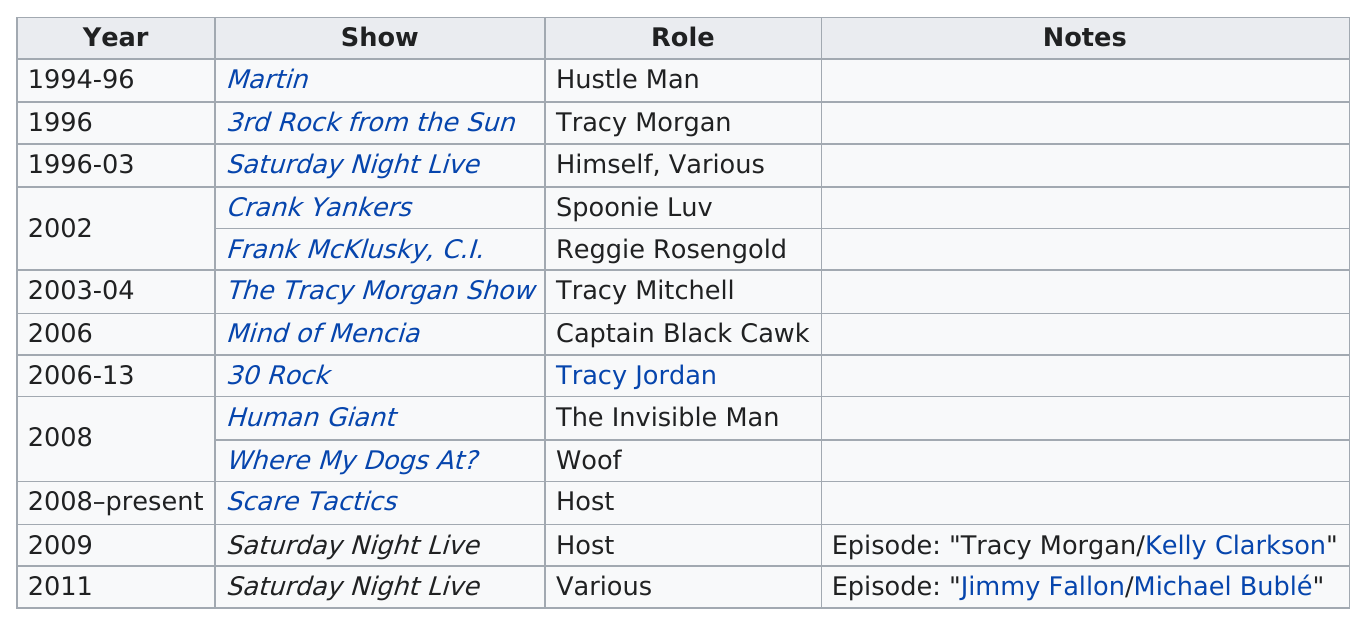Highlight a few significant elements in this photo. Tracy Morgan appeared on 30 Rock for 7 years. When did Morgan begin hosting Scare Tactics? It began in 2008. 